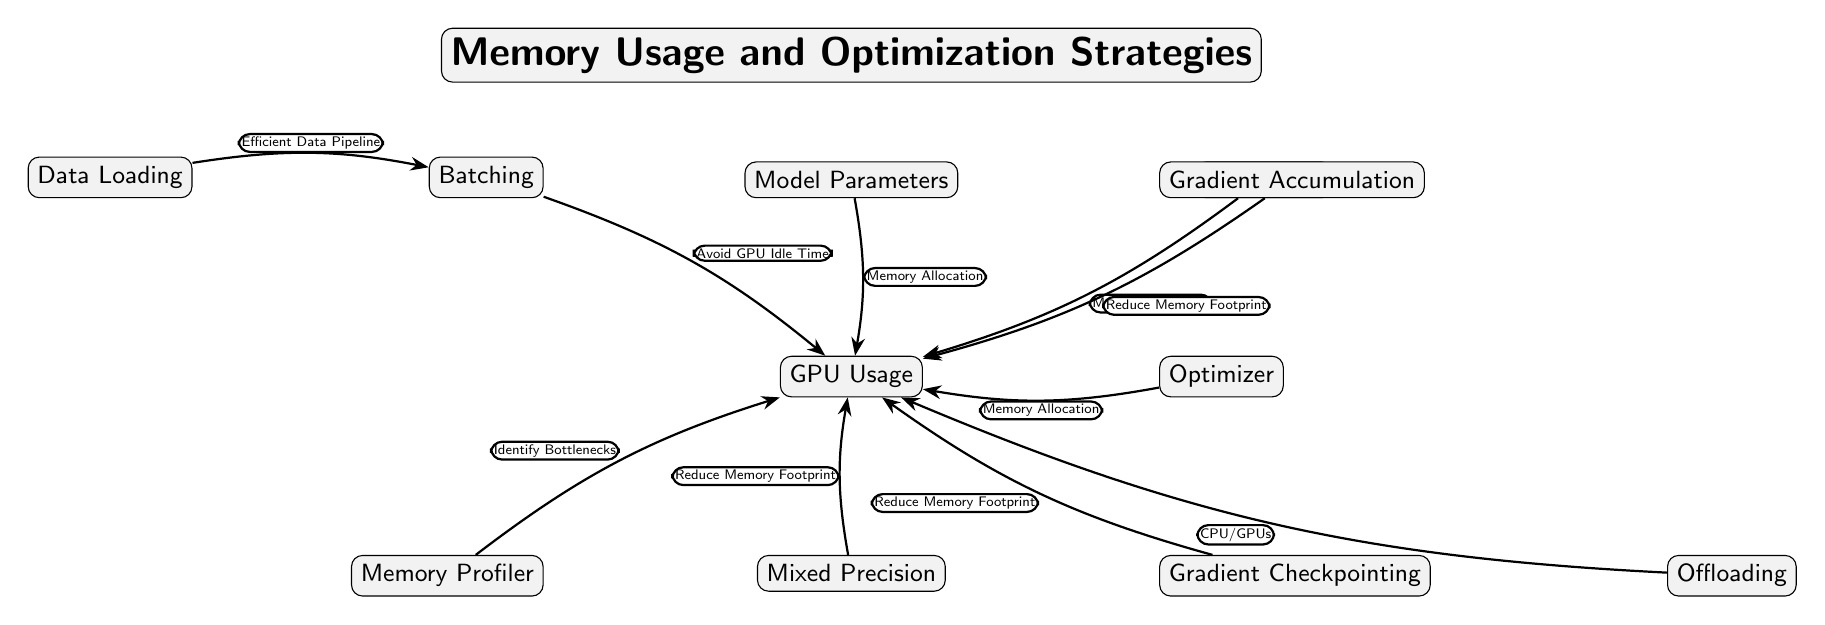What are the two primary strategies mentioned to reduce memory footprint? The diagram includes two specific nodes: "Mixed Precision" and "Gradient Checkpointing." Both of these nodes directly connect to "GPU Usage" with the label "Reduce Memory Footprint," indicating they are strategies to address memory concerns.
Answer: Mixed Precision, Gradient Checkpointing How many total nodes are present in the diagram? Counting each labeled node: "Data Loading," "Batching," "GPU Usage," "Model Parameters," "Activations," "Optimizer," "Memory Profiler," "Mixed Precision," "Gradient Checkpointing," "Offloading," and "Gradient Accumulation," we find a total of 11 nodes.
Answer: 11 What node in the diagram is associated with identifying memory bottlenecks? This node is labeled "Memory Profiler," which has a direct edge leading to "GPU Usage" with the description "Identify Bottlenecks."
Answer: Memory Profiler Which nodes are connected to "GPU Usage" for memory allocation? The nodes that connect to "GPU Usage" for memory allocation are "Model Parameters," "Activations," and "Optimizer." Each of these nodes sends information related to memory to the "GPU Usage" node.
Answer: Model Parameters, Activations, Optimizer Which strategy involves reducing memory during the training process and is linked to both "Mixed Precision" and "Gradient Accumulation"? The strategy linked to both nodes focuses on "Reduce Memory Footprint," and this label indicates its goal to lessen memory usage during training by implementing lesser precision and accumulating gradients.
Answer: Reduce Memory Footprint How does "Batching" relate to "GPU Usage"? "Batching" is connected to "GPU Usage" with the relationship labeled "Avoid GPU Idle Time," indicating that effective batching strategies can prevent idle time on the GPU, optimizing resource utilization.
Answer: Avoid GPU Idle Time How many edges are in the diagram? By counting each connection drawn between nodes, including all directed edges through the relationships provided, we identify 9 edges in total bridging different concepts in the diagram.
Answer: 9 Which node can be used for offloading to CPUs or GPUs as mentioned in the diagram? The node identified for offloading capabilities is "Offloading." Its connection implies a strategy for distributing memory or computation tasks between CPU and GPU to enhance efficiency.
Answer: Offloading 